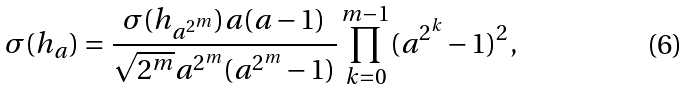<formula> <loc_0><loc_0><loc_500><loc_500>\sigma ( h _ { a } ) = \frac { \sigma ( h _ { a ^ { 2 ^ { m } } } ) a ( a - 1 ) } { \sqrt { 2 ^ { m } } a ^ { 2 ^ { m } } ( a ^ { 2 ^ { m } } - 1 ) } \prod _ { k = 0 } ^ { m - 1 } ( a ^ { 2 ^ { k } } - 1 ) ^ { 2 } ,</formula> 